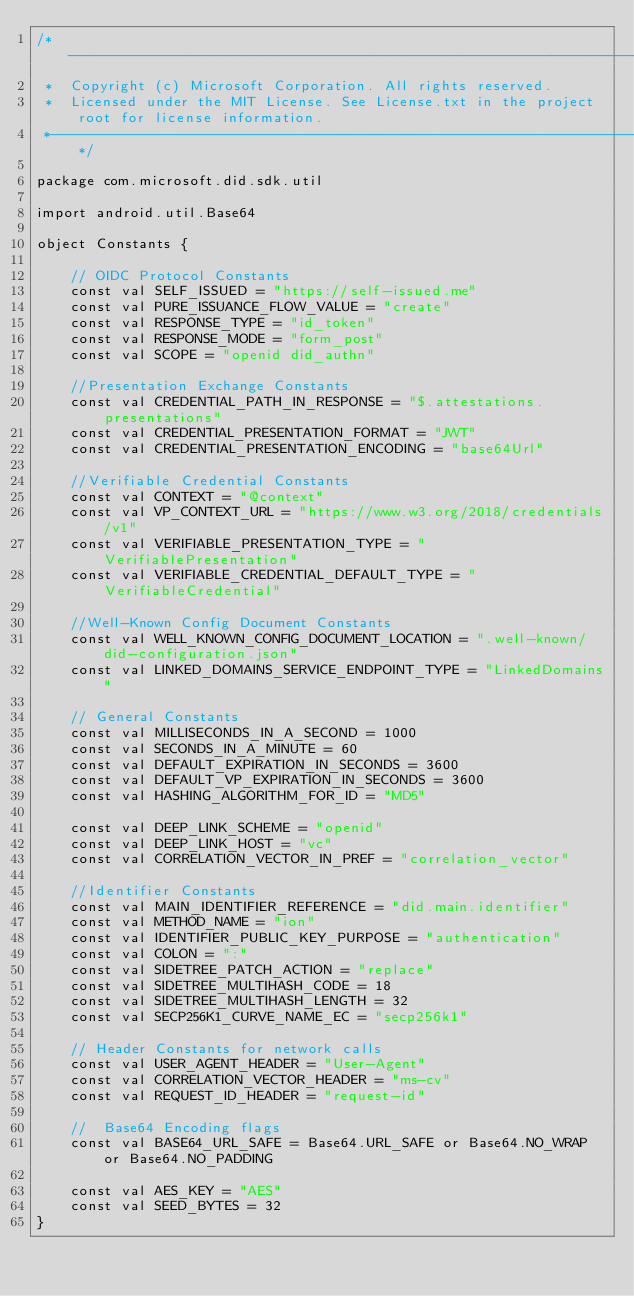Convert code to text. <code><loc_0><loc_0><loc_500><loc_500><_Kotlin_>/*---------------------------------------------------------------------------------------------
 *  Copyright (c) Microsoft Corporation. All rights reserved.
 *  Licensed under the MIT License. See License.txt in the project root for license information.
 *--------------------------------------------------------------------------------------------*/

package com.microsoft.did.sdk.util

import android.util.Base64

object Constants {

    // OIDC Protocol Constants
    const val SELF_ISSUED = "https://self-issued.me"
    const val PURE_ISSUANCE_FLOW_VALUE = "create"
    const val RESPONSE_TYPE = "id_token"
    const val RESPONSE_MODE = "form_post"
    const val SCOPE = "openid did_authn"

    //Presentation Exchange Constants
    const val CREDENTIAL_PATH_IN_RESPONSE = "$.attestations.presentations"
    const val CREDENTIAL_PRESENTATION_FORMAT = "JWT"
    const val CREDENTIAL_PRESENTATION_ENCODING = "base64Url"

    //Verifiable Credential Constants
    const val CONTEXT = "@context"
    const val VP_CONTEXT_URL = "https://www.w3.org/2018/credentials/v1"
    const val VERIFIABLE_PRESENTATION_TYPE = "VerifiablePresentation"
    const val VERIFIABLE_CREDENTIAL_DEFAULT_TYPE = "VerifiableCredential"

    //Well-Known Config Document Constants
    const val WELL_KNOWN_CONFIG_DOCUMENT_LOCATION = ".well-known/did-configuration.json"
    const val LINKED_DOMAINS_SERVICE_ENDPOINT_TYPE = "LinkedDomains"

    // General Constants
    const val MILLISECONDS_IN_A_SECOND = 1000
    const val SECONDS_IN_A_MINUTE = 60
    const val DEFAULT_EXPIRATION_IN_SECONDS = 3600
    const val DEFAULT_VP_EXPIRATION_IN_SECONDS = 3600
    const val HASHING_ALGORITHM_FOR_ID = "MD5"

    const val DEEP_LINK_SCHEME = "openid"
    const val DEEP_LINK_HOST = "vc"
    const val CORRELATION_VECTOR_IN_PREF = "correlation_vector"

    //Identifier Constants
    const val MAIN_IDENTIFIER_REFERENCE = "did.main.identifier"
    const val METHOD_NAME = "ion"
    const val IDENTIFIER_PUBLIC_KEY_PURPOSE = "authentication"
    const val COLON = ":"
    const val SIDETREE_PATCH_ACTION = "replace"
    const val SIDETREE_MULTIHASH_CODE = 18
    const val SIDETREE_MULTIHASH_LENGTH = 32
    const val SECP256K1_CURVE_NAME_EC = "secp256k1"

    // Header Constants for network calls
    const val USER_AGENT_HEADER = "User-Agent"
    const val CORRELATION_VECTOR_HEADER = "ms-cv"
    const val REQUEST_ID_HEADER = "request-id"

    //  Base64 Encoding flags
    const val BASE64_URL_SAFE = Base64.URL_SAFE or Base64.NO_WRAP or Base64.NO_PADDING

    const val AES_KEY = "AES"
    const val SEED_BYTES = 32
}</code> 